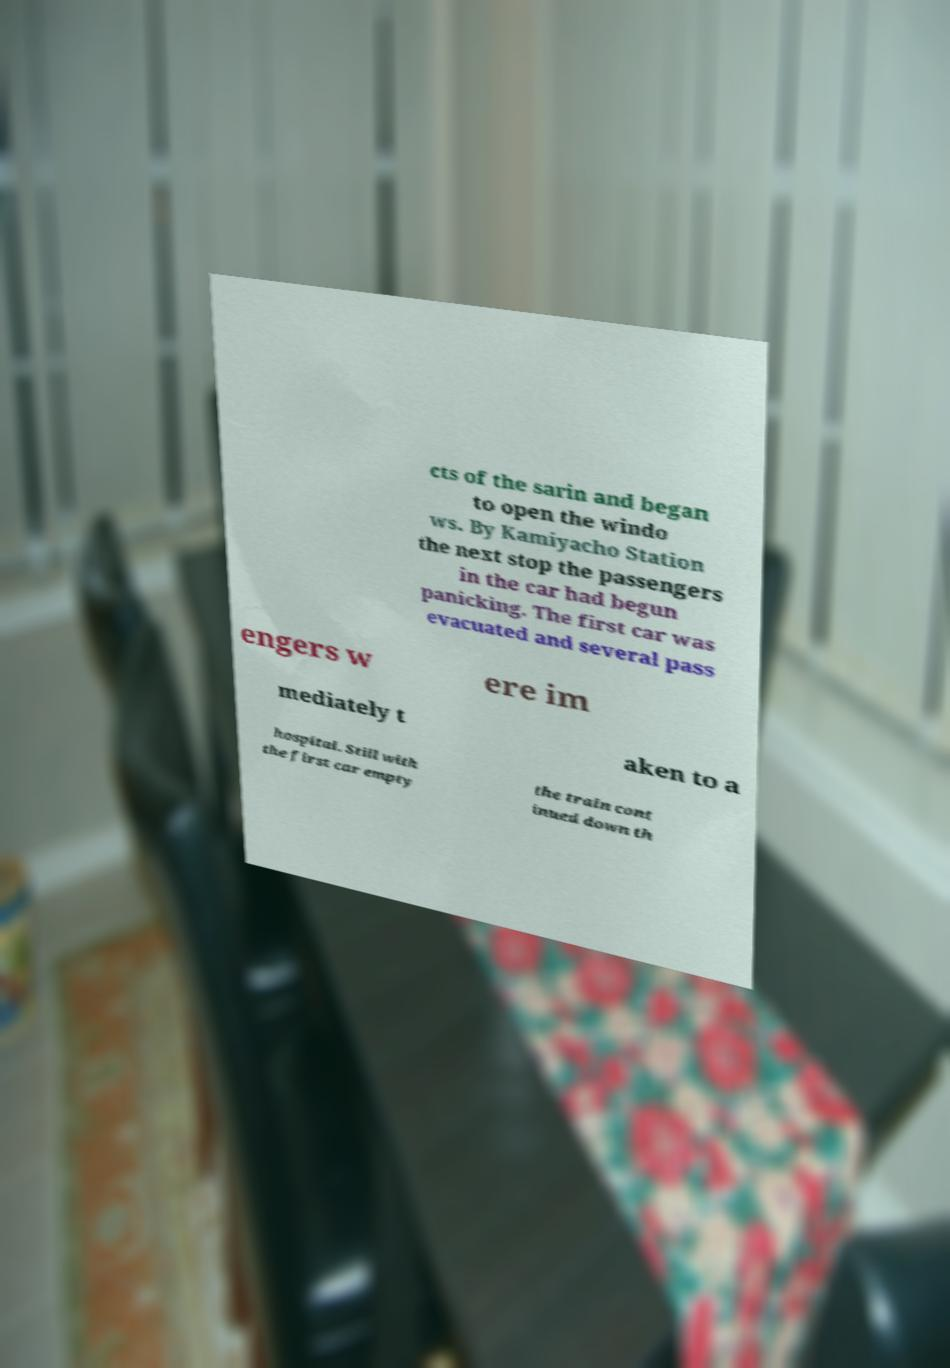Could you extract and type out the text from this image? cts of the sarin and began to open the windo ws. By Kamiyacho Station the next stop the passengers in the car had begun panicking. The first car was evacuated and several pass engers w ere im mediately t aken to a hospital. Still with the first car empty the train cont inued down th 